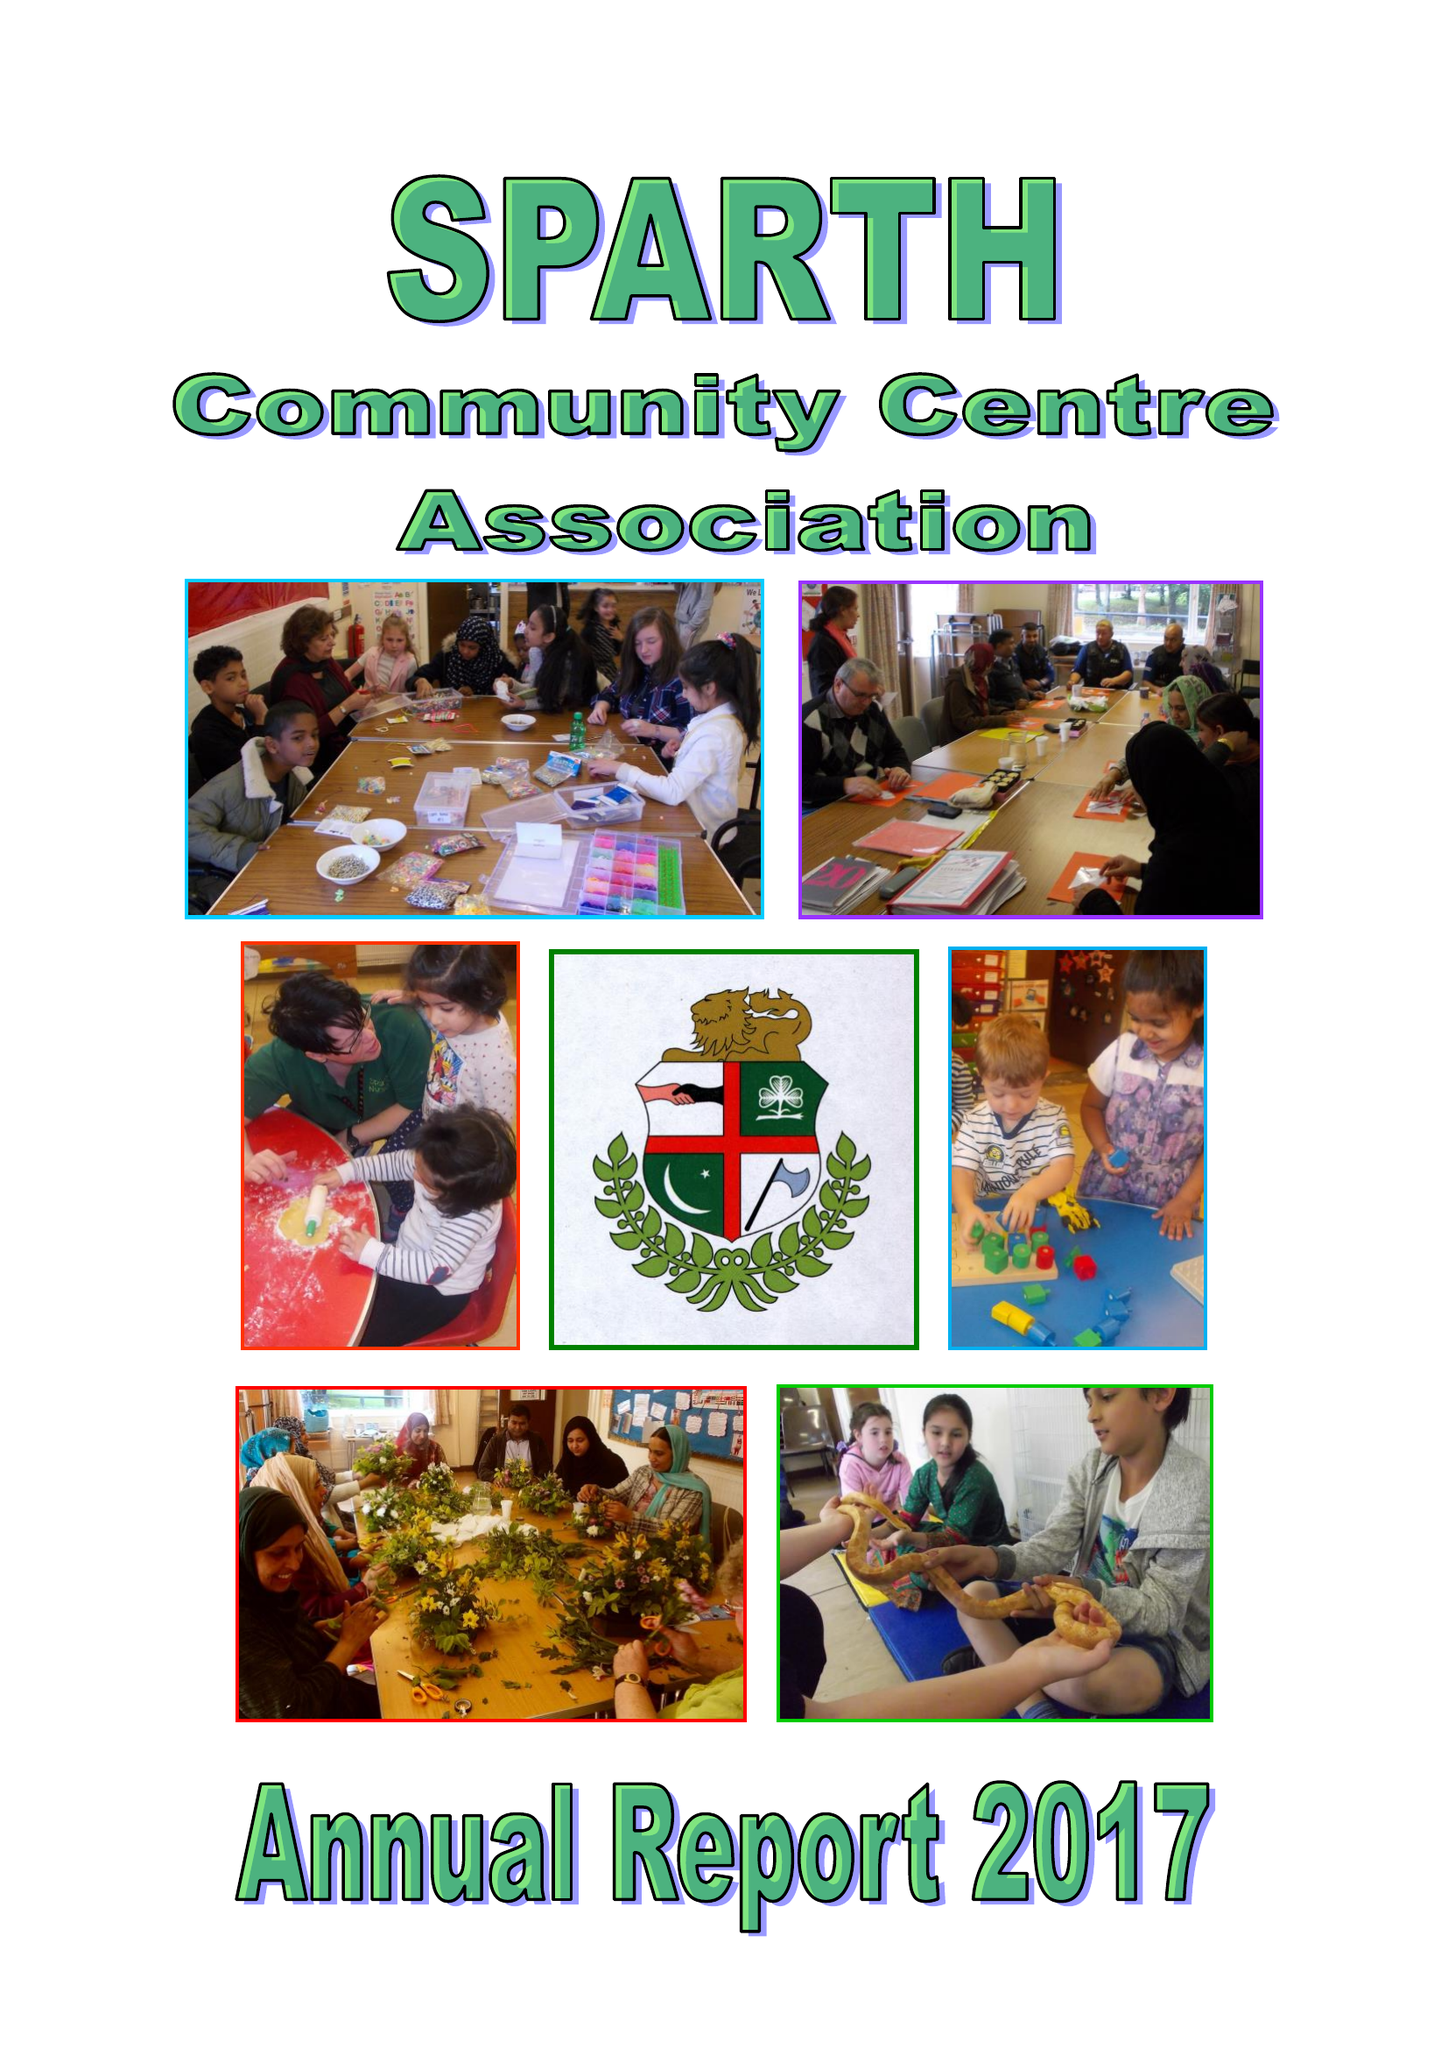What is the value for the charity_name?
Answer the question using a single word or phrase. Sparth Community Centre Association 